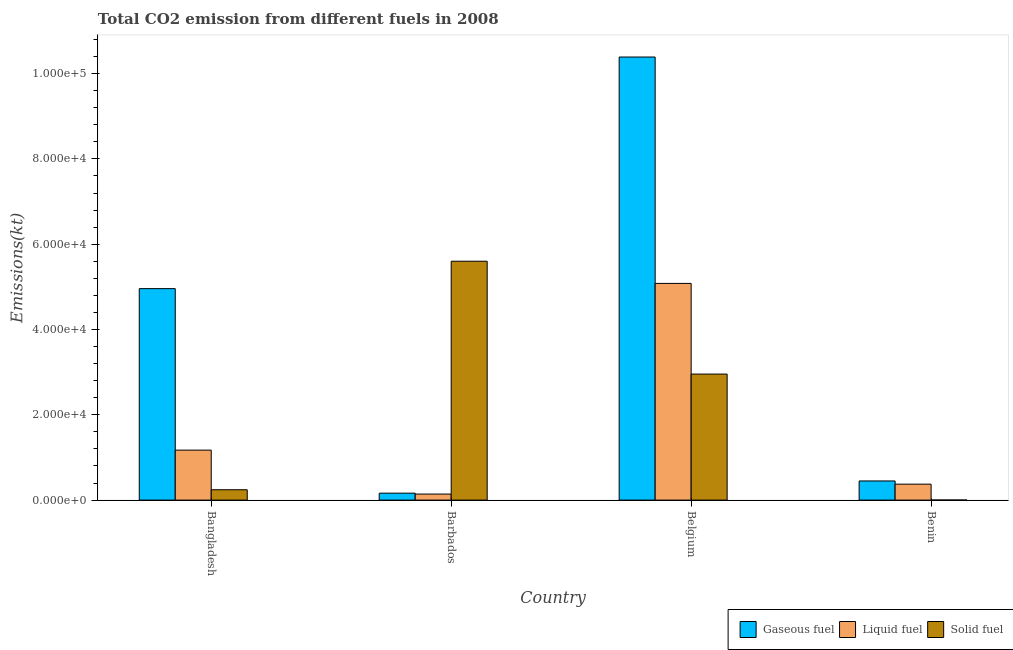How many different coloured bars are there?
Keep it short and to the point. 3. Are the number of bars per tick equal to the number of legend labels?
Your response must be concise. Yes. How many bars are there on the 1st tick from the left?
Keep it short and to the point. 3. What is the label of the 2nd group of bars from the left?
Make the answer very short. Barbados. In how many cases, is the number of bars for a given country not equal to the number of legend labels?
Your response must be concise. 0. What is the amount of co2 emissions from gaseous fuel in Belgium?
Your answer should be compact. 1.04e+05. Across all countries, what is the maximum amount of co2 emissions from liquid fuel?
Keep it short and to the point. 5.08e+04. Across all countries, what is the minimum amount of co2 emissions from solid fuel?
Provide a short and direct response. 14.67. In which country was the amount of co2 emissions from liquid fuel maximum?
Ensure brevity in your answer.  Belgium. In which country was the amount of co2 emissions from gaseous fuel minimum?
Your answer should be very brief. Barbados. What is the total amount of co2 emissions from gaseous fuel in the graph?
Your answer should be very brief. 1.60e+05. What is the difference between the amount of co2 emissions from solid fuel in Belgium and that in Benin?
Offer a very short reply. 2.95e+04. What is the difference between the amount of co2 emissions from solid fuel in Belgium and the amount of co2 emissions from liquid fuel in Barbados?
Offer a very short reply. 2.81e+04. What is the average amount of co2 emissions from solid fuel per country?
Your answer should be compact. 2.20e+04. What is the difference between the amount of co2 emissions from liquid fuel and amount of co2 emissions from solid fuel in Benin?
Make the answer very short. 3725.67. What is the ratio of the amount of co2 emissions from solid fuel in Belgium to that in Benin?
Your response must be concise. 2014.5. What is the difference between the highest and the second highest amount of co2 emissions from solid fuel?
Your response must be concise. 2.65e+04. What is the difference between the highest and the lowest amount of co2 emissions from solid fuel?
Your answer should be compact. 5.60e+04. Is the sum of the amount of co2 emissions from liquid fuel in Barbados and Belgium greater than the maximum amount of co2 emissions from solid fuel across all countries?
Provide a short and direct response. No. What does the 2nd bar from the left in Benin represents?
Offer a very short reply. Liquid fuel. What does the 3rd bar from the right in Bangladesh represents?
Your answer should be compact. Gaseous fuel. Is it the case that in every country, the sum of the amount of co2 emissions from gaseous fuel and amount of co2 emissions from liquid fuel is greater than the amount of co2 emissions from solid fuel?
Offer a very short reply. No. Are all the bars in the graph horizontal?
Offer a terse response. No. What is the difference between two consecutive major ticks on the Y-axis?
Your response must be concise. 2.00e+04. Where does the legend appear in the graph?
Give a very brief answer. Bottom right. How are the legend labels stacked?
Your response must be concise. Horizontal. What is the title of the graph?
Provide a short and direct response. Total CO2 emission from different fuels in 2008. What is the label or title of the Y-axis?
Give a very brief answer. Emissions(kt). What is the Emissions(kt) of Gaseous fuel in Bangladesh?
Your response must be concise. 4.96e+04. What is the Emissions(kt) in Liquid fuel in Bangladesh?
Provide a succinct answer. 1.17e+04. What is the Emissions(kt) in Solid fuel in Bangladesh?
Provide a short and direct response. 2427.55. What is the Emissions(kt) of Gaseous fuel in Barbados?
Ensure brevity in your answer.  1628.15. What is the Emissions(kt) of Liquid fuel in Barbados?
Your response must be concise. 1415.46. What is the Emissions(kt) in Solid fuel in Barbados?
Your answer should be very brief. 5.60e+04. What is the Emissions(kt) of Gaseous fuel in Belgium?
Offer a very short reply. 1.04e+05. What is the Emissions(kt) in Liquid fuel in Belgium?
Your answer should be very brief. 5.08e+04. What is the Emissions(kt) of Solid fuel in Belgium?
Provide a succinct answer. 2.95e+04. What is the Emissions(kt) of Gaseous fuel in Benin?
Provide a short and direct response. 4488.41. What is the Emissions(kt) of Liquid fuel in Benin?
Ensure brevity in your answer.  3740.34. What is the Emissions(kt) of Solid fuel in Benin?
Your response must be concise. 14.67. Across all countries, what is the maximum Emissions(kt) in Gaseous fuel?
Offer a terse response. 1.04e+05. Across all countries, what is the maximum Emissions(kt) of Liquid fuel?
Your response must be concise. 5.08e+04. Across all countries, what is the maximum Emissions(kt) of Solid fuel?
Make the answer very short. 5.60e+04. Across all countries, what is the minimum Emissions(kt) of Gaseous fuel?
Your answer should be compact. 1628.15. Across all countries, what is the minimum Emissions(kt) in Liquid fuel?
Your answer should be very brief. 1415.46. Across all countries, what is the minimum Emissions(kt) of Solid fuel?
Your answer should be very brief. 14.67. What is the total Emissions(kt) in Gaseous fuel in the graph?
Offer a terse response. 1.60e+05. What is the total Emissions(kt) of Liquid fuel in the graph?
Give a very brief answer. 6.77e+04. What is the total Emissions(kt) of Solid fuel in the graph?
Your response must be concise. 8.80e+04. What is the difference between the Emissions(kt) in Gaseous fuel in Bangladesh and that in Barbados?
Ensure brevity in your answer.  4.80e+04. What is the difference between the Emissions(kt) of Liquid fuel in Bangladesh and that in Barbados?
Offer a terse response. 1.03e+04. What is the difference between the Emissions(kt) of Solid fuel in Bangladesh and that in Barbados?
Your answer should be compact. -5.36e+04. What is the difference between the Emissions(kt) of Gaseous fuel in Bangladesh and that in Belgium?
Offer a terse response. -5.43e+04. What is the difference between the Emissions(kt) in Liquid fuel in Bangladesh and that in Belgium?
Offer a terse response. -3.91e+04. What is the difference between the Emissions(kt) in Solid fuel in Bangladesh and that in Belgium?
Give a very brief answer. -2.71e+04. What is the difference between the Emissions(kt) in Gaseous fuel in Bangladesh and that in Benin?
Your response must be concise. 4.51e+04. What is the difference between the Emissions(kt) of Liquid fuel in Bangladesh and that in Benin?
Your answer should be very brief. 7975.73. What is the difference between the Emissions(kt) of Solid fuel in Bangladesh and that in Benin?
Offer a very short reply. 2412.89. What is the difference between the Emissions(kt) in Gaseous fuel in Barbados and that in Belgium?
Keep it short and to the point. -1.02e+05. What is the difference between the Emissions(kt) of Liquid fuel in Barbados and that in Belgium?
Provide a succinct answer. -4.94e+04. What is the difference between the Emissions(kt) of Solid fuel in Barbados and that in Belgium?
Provide a short and direct response. 2.65e+04. What is the difference between the Emissions(kt) of Gaseous fuel in Barbados and that in Benin?
Offer a very short reply. -2860.26. What is the difference between the Emissions(kt) of Liquid fuel in Barbados and that in Benin?
Keep it short and to the point. -2324.88. What is the difference between the Emissions(kt) of Solid fuel in Barbados and that in Benin?
Offer a terse response. 5.60e+04. What is the difference between the Emissions(kt) of Gaseous fuel in Belgium and that in Benin?
Your answer should be compact. 9.94e+04. What is the difference between the Emissions(kt) of Liquid fuel in Belgium and that in Benin?
Ensure brevity in your answer.  4.71e+04. What is the difference between the Emissions(kt) in Solid fuel in Belgium and that in Benin?
Make the answer very short. 2.95e+04. What is the difference between the Emissions(kt) of Gaseous fuel in Bangladesh and the Emissions(kt) of Liquid fuel in Barbados?
Provide a succinct answer. 4.82e+04. What is the difference between the Emissions(kt) of Gaseous fuel in Bangladesh and the Emissions(kt) of Solid fuel in Barbados?
Your response must be concise. -6424.58. What is the difference between the Emissions(kt) in Liquid fuel in Bangladesh and the Emissions(kt) in Solid fuel in Barbados?
Your response must be concise. -4.43e+04. What is the difference between the Emissions(kt) of Gaseous fuel in Bangladesh and the Emissions(kt) of Liquid fuel in Belgium?
Keep it short and to the point. -1221.11. What is the difference between the Emissions(kt) in Gaseous fuel in Bangladesh and the Emissions(kt) in Solid fuel in Belgium?
Make the answer very short. 2.00e+04. What is the difference between the Emissions(kt) of Liquid fuel in Bangladesh and the Emissions(kt) of Solid fuel in Belgium?
Your response must be concise. -1.78e+04. What is the difference between the Emissions(kt) in Gaseous fuel in Bangladesh and the Emissions(kt) in Liquid fuel in Benin?
Offer a terse response. 4.58e+04. What is the difference between the Emissions(kt) in Gaseous fuel in Bangladesh and the Emissions(kt) in Solid fuel in Benin?
Your answer should be compact. 4.96e+04. What is the difference between the Emissions(kt) in Liquid fuel in Bangladesh and the Emissions(kt) in Solid fuel in Benin?
Provide a short and direct response. 1.17e+04. What is the difference between the Emissions(kt) in Gaseous fuel in Barbados and the Emissions(kt) in Liquid fuel in Belgium?
Provide a short and direct response. -4.92e+04. What is the difference between the Emissions(kt) in Gaseous fuel in Barbados and the Emissions(kt) in Solid fuel in Belgium?
Your answer should be very brief. -2.79e+04. What is the difference between the Emissions(kt) in Liquid fuel in Barbados and the Emissions(kt) in Solid fuel in Belgium?
Offer a terse response. -2.81e+04. What is the difference between the Emissions(kt) of Gaseous fuel in Barbados and the Emissions(kt) of Liquid fuel in Benin?
Your answer should be compact. -2112.19. What is the difference between the Emissions(kt) of Gaseous fuel in Barbados and the Emissions(kt) of Solid fuel in Benin?
Ensure brevity in your answer.  1613.48. What is the difference between the Emissions(kt) in Liquid fuel in Barbados and the Emissions(kt) in Solid fuel in Benin?
Provide a succinct answer. 1400.79. What is the difference between the Emissions(kt) of Gaseous fuel in Belgium and the Emissions(kt) of Liquid fuel in Benin?
Give a very brief answer. 1.00e+05. What is the difference between the Emissions(kt) of Gaseous fuel in Belgium and the Emissions(kt) of Solid fuel in Benin?
Your response must be concise. 1.04e+05. What is the difference between the Emissions(kt) of Liquid fuel in Belgium and the Emissions(kt) of Solid fuel in Benin?
Offer a terse response. 5.08e+04. What is the average Emissions(kt) of Gaseous fuel per country?
Give a very brief answer. 3.99e+04. What is the average Emissions(kt) of Liquid fuel per country?
Your answer should be very brief. 1.69e+04. What is the average Emissions(kt) in Solid fuel per country?
Give a very brief answer. 2.20e+04. What is the difference between the Emissions(kt) in Gaseous fuel and Emissions(kt) in Liquid fuel in Bangladesh?
Ensure brevity in your answer.  3.79e+04. What is the difference between the Emissions(kt) in Gaseous fuel and Emissions(kt) in Solid fuel in Bangladesh?
Your response must be concise. 4.72e+04. What is the difference between the Emissions(kt) of Liquid fuel and Emissions(kt) of Solid fuel in Bangladesh?
Make the answer very short. 9288.51. What is the difference between the Emissions(kt) in Gaseous fuel and Emissions(kt) in Liquid fuel in Barbados?
Keep it short and to the point. 212.69. What is the difference between the Emissions(kt) in Gaseous fuel and Emissions(kt) in Solid fuel in Barbados?
Offer a very short reply. -5.44e+04. What is the difference between the Emissions(kt) of Liquid fuel and Emissions(kt) of Solid fuel in Barbados?
Your response must be concise. -5.46e+04. What is the difference between the Emissions(kt) of Gaseous fuel and Emissions(kt) of Liquid fuel in Belgium?
Make the answer very short. 5.31e+04. What is the difference between the Emissions(kt) in Gaseous fuel and Emissions(kt) in Solid fuel in Belgium?
Make the answer very short. 7.43e+04. What is the difference between the Emissions(kt) in Liquid fuel and Emissions(kt) in Solid fuel in Belgium?
Ensure brevity in your answer.  2.13e+04. What is the difference between the Emissions(kt) of Gaseous fuel and Emissions(kt) of Liquid fuel in Benin?
Make the answer very short. 748.07. What is the difference between the Emissions(kt) of Gaseous fuel and Emissions(kt) of Solid fuel in Benin?
Offer a terse response. 4473.74. What is the difference between the Emissions(kt) of Liquid fuel and Emissions(kt) of Solid fuel in Benin?
Give a very brief answer. 3725.67. What is the ratio of the Emissions(kt) in Gaseous fuel in Bangladesh to that in Barbados?
Offer a very short reply. 30.45. What is the ratio of the Emissions(kt) in Liquid fuel in Bangladesh to that in Barbados?
Ensure brevity in your answer.  8.28. What is the ratio of the Emissions(kt) in Solid fuel in Bangladesh to that in Barbados?
Offer a very short reply. 0.04. What is the ratio of the Emissions(kt) of Gaseous fuel in Bangladesh to that in Belgium?
Keep it short and to the point. 0.48. What is the ratio of the Emissions(kt) in Liquid fuel in Bangladesh to that in Belgium?
Your response must be concise. 0.23. What is the ratio of the Emissions(kt) of Solid fuel in Bangladesh to that in Belgium?
Provide a succinct answer. 0.08. What is the ratio of the Emissions(kt) in Gaseous fuel in Bangladesh to that in Benin?
Your answer should be very brief. 11.05. What is the ratio of the Emissions(kt) in Liquid fuel in Bangladesh to that in Benin?
Your response must be concise. 3.13. What is the ratio of the Emissions(kt) in Solid fuel in Bangladesh to that in Benin?
Your answer should be compact. 165.5. What is the ratio of the Emissions(kt) of Gaseous fuel in Barbados to that in Belgium?
Your answer should be compact. 0.02. What is the ratio of the Emissions(kt) of Liquid fuel in Barbados to that in Belgium?
Ensure brevity in your answer.  0.03. What is the ratio of the Emissions(kt) in Solid fuel in Barbados to that in Belgium?
Make the answer very short. 1.9. What is the ratio of the Emissions(kt) in Gaseous fuel in Barbados to that in Benin?
Your answer should be compact. 0.36. What is the ratio of the Emissions(kt) in Liquid fuel in Barbados to that in Benin?
Ensure brevity in your answer.  0.38. What is the ratio of the Emissions(kt) in Solid fuel in Barbados to that in Benin?
Provide a succinct answer. 3818.25. What is the ratio of the Emissions(kt) of Gaseous fuel in Belgium to that in Benin?
Provide a succinct answer. 23.14. What is the ratio of the Emissions(kt) in Liquid fuel in Belgium to that in Benin?
Your response must be concise. 13.58. What is the ratio of the Emissions(kt) of Solid fuel in Belgium to that in Benin?
Your answer should be compact. 2014.5. What is the difference between the highest and the second highest Emissions(kt) of Gaseous fuel?
Ensure brevity in your answer.  5.43e+04. What is the difference between the highest and the second highest Emissions(kt) of Liquid fuel?
Your response must be concise. 3.91e+04. What is the difference between the highest and the second highest Emissions(kt) in Solid fuel?
Keep it short and to the point. 2.65e+04. What is the difference between the highest and the lowest Emissions(kt) in Gaseous fuel?
Your answer should be very brief. 1.02e+05. What is the difference between the highest and the lowest Emissions(kt) of Liquid fuel?
Make the answer very short. 4.94e+04. What is the difference between the highest and the lowest Emissions(kt) of Solid fuel?
Your answer should be very brief. 5.60e+04. 